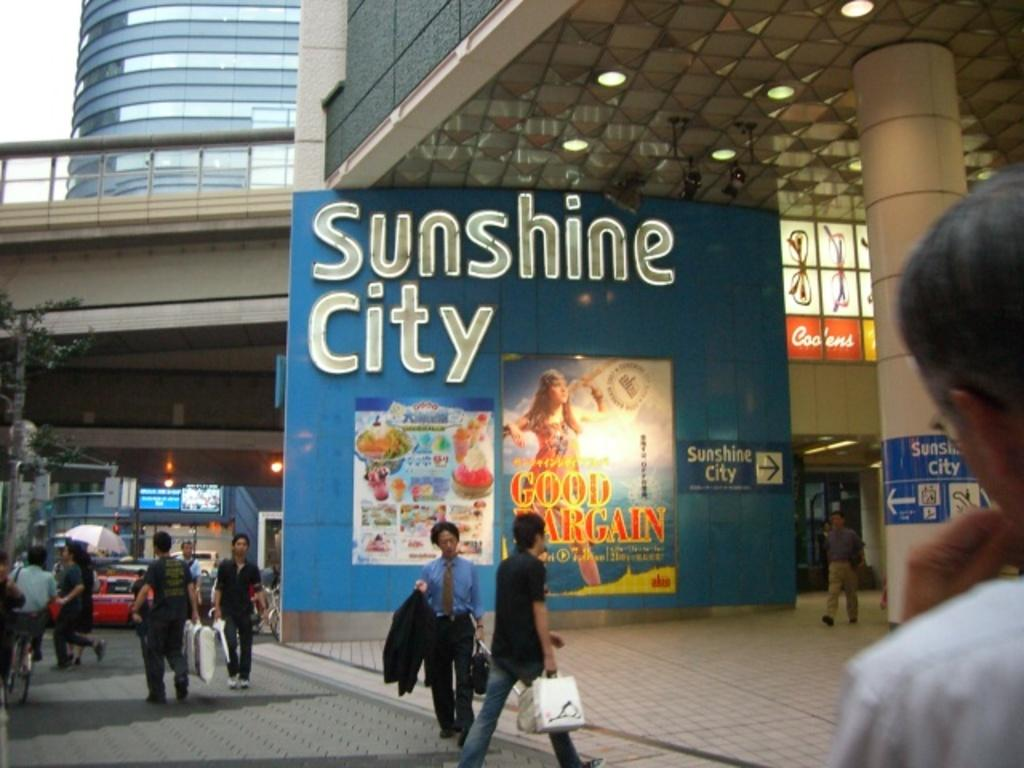<image>
Summarize the visual content of the image. The sign for Sunshine City is clearly visible on a blue wall. 